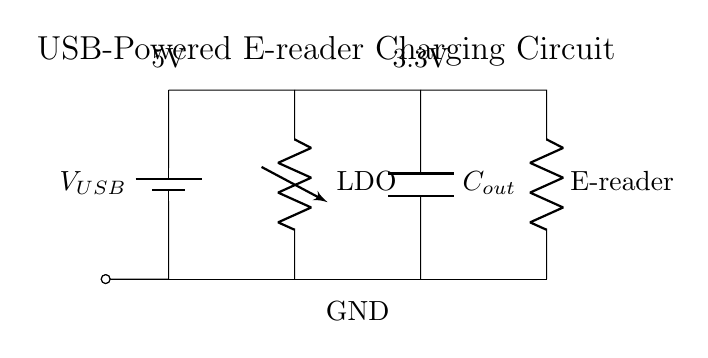What is the input voltage of this circuit? The input voltage is indicated as 5V, which is specified near the USB battery symbol in the circuit.
Answer: 5V What component regulates the voltage output? The component that regulates the voltage output is labeled as LDO, which stands for Low Drop-Out regulator. It provides a stable output voltage after receiving the input voltage.
Answer: LDO What is the voltage output for the e-reader? The output voltage for the e-reader is specified as 3.3V, shown next to the output capacitor in the circuit diagram.
Answer: 3.3V Which component stores energy in this charging circuit? The component that stores energy in this charging circuit is the capacitor, specifically labeled as C_out. It smooths the output voltage for the e-reader.
Answer: C_out How many short connections are there in this circuit? There are a total of four short connections, which connect the components to a common ground and link the input and output sections together.
Answer: Four What is the main purpose of this circuit? The main purpose of this circuit is to charge the e-reader efficiently while regulating the voltage to a safe level for operation.
Answer: To charge the e-reader What is the significance of the ground connections in this circuit? The ground connections provide a common return path for the electric current, ensuring that the circuit operates safely and effectively by avoiding short circuits.
Answer: Common return path 